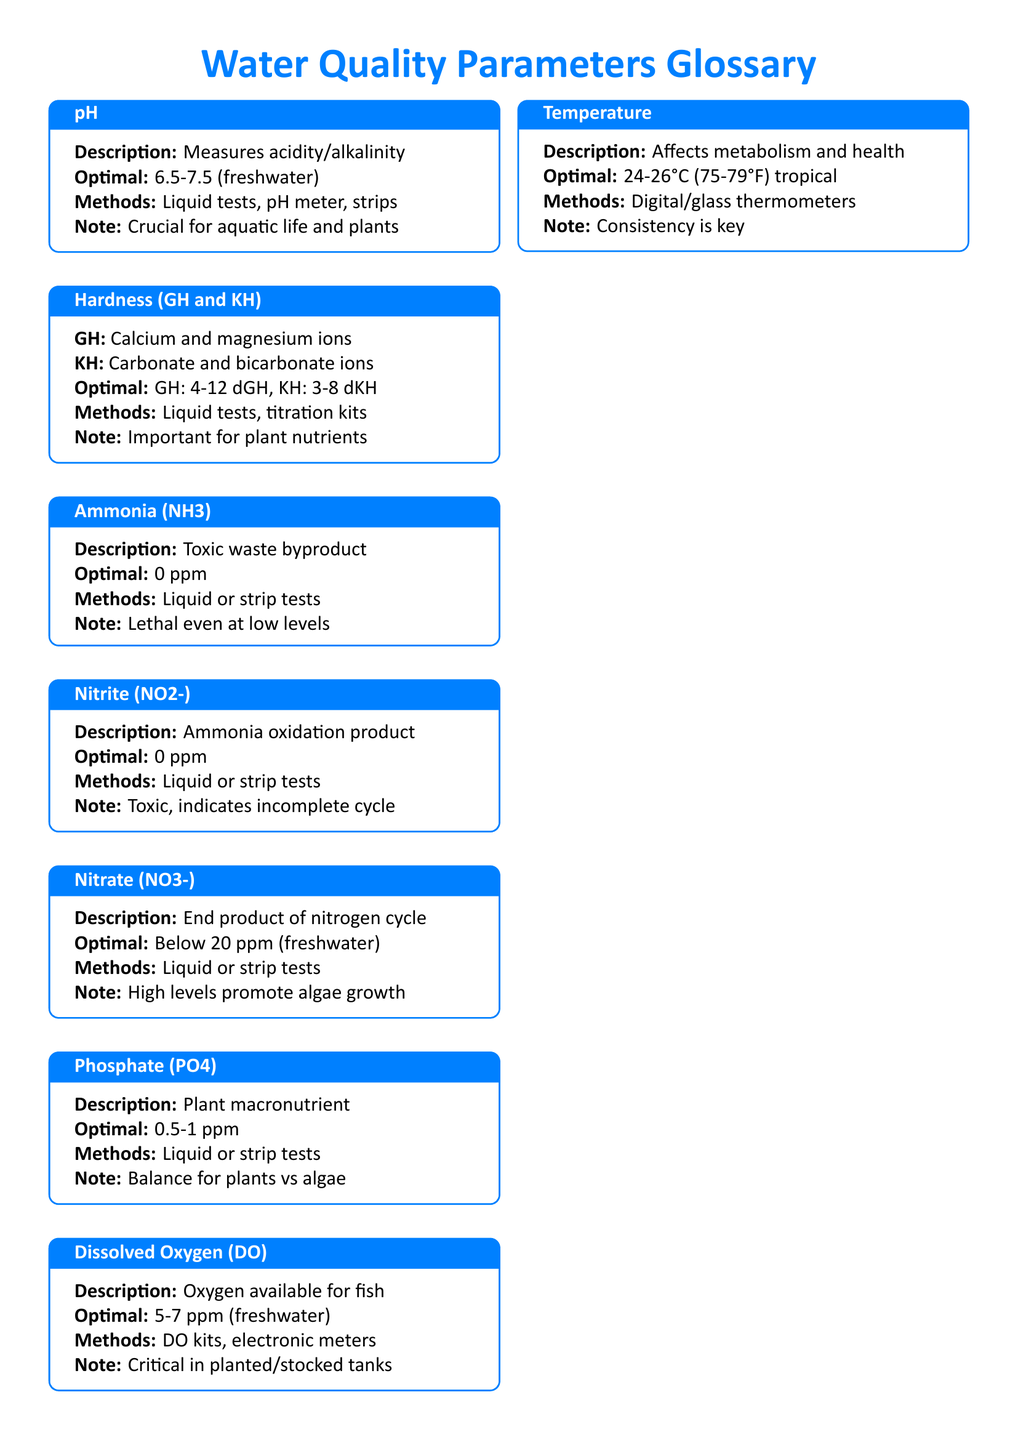What is the optimal pH for freshwater? The optimal pH range for freshwater is specifically mentioned in the document under the pH parameter.
Answer: 6.5-7.5 What is the description of Nitrate? The Nitrate entry includes a description that summarizes its role in the nitrogen cycle.
Answer: End product of nitrogen cycle What is the optimal level of Ammonia? The document states the optimal level of Ammonia very clearly in its section.
Answer: 0 ppm What type of testing method is used for Dissolved Oxygen? The information regarding testing methods for Dissolved Oxygen specifies the tools available for measurement.
Answer: DO kits, electronic meters What is the common range for Water Hardness (GH)? The document provides optimal ranges for both General Hardness (GH) and Carbonate Hardness (KH).
Answer: 4-12 dGH What do electronic meters measure? Electronic meters are mentioned in the section about Testing Tools, indicating their uses.
Answer: pH, DO, temperature What should aquarists do weekly? The document provides a note under Aquarist's Notes about testing frequency.
Answer: Test water weekly for stability What is a possible danger of high Nitrate levels? The document notes the impact of high Nitrate levels on aquatic life, which is crucial for ongoing health.
Answer: Promote algae growth 